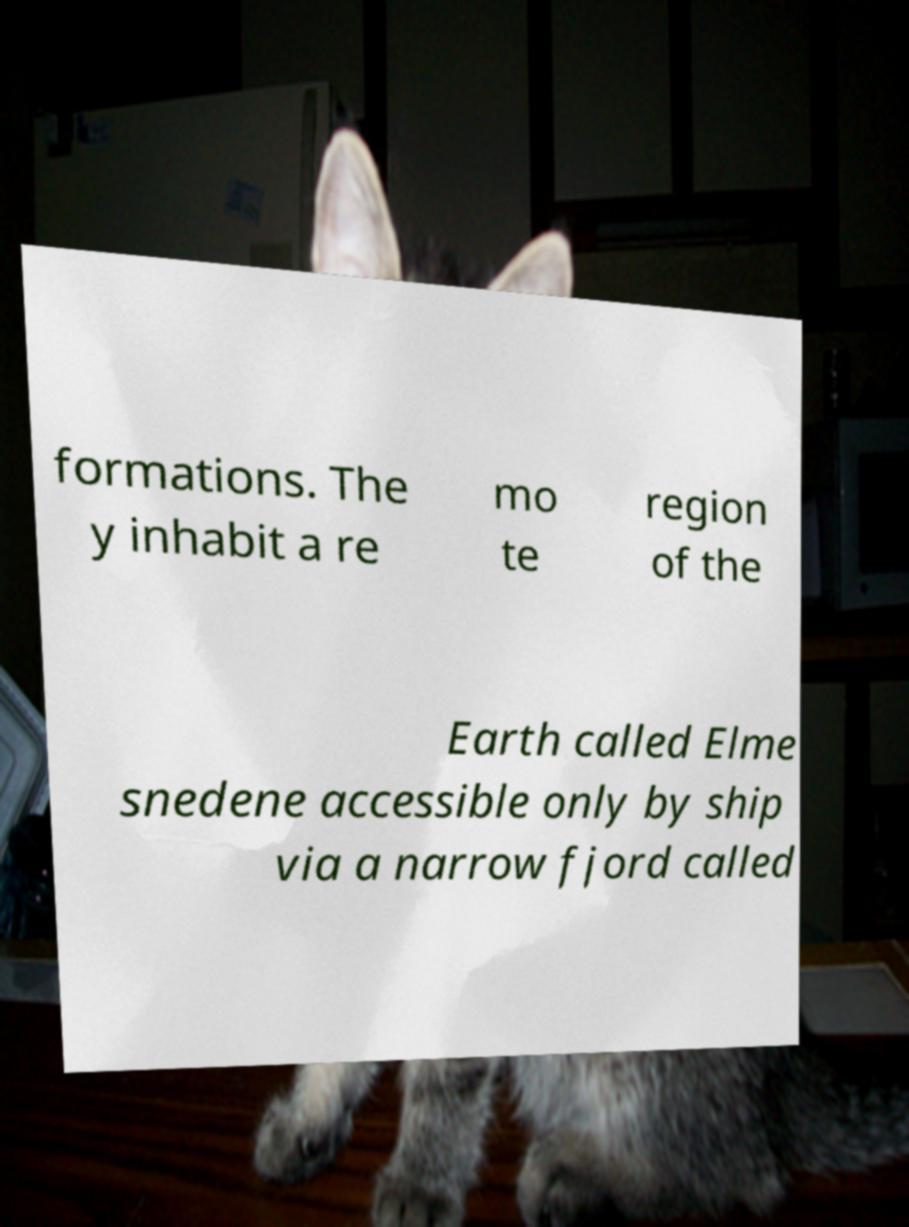Could you extract and type out the text from this image? formations. The y inhabit a re mo te region of the Earth called Elme snedene accessible only by ship via a narrow fjord called 